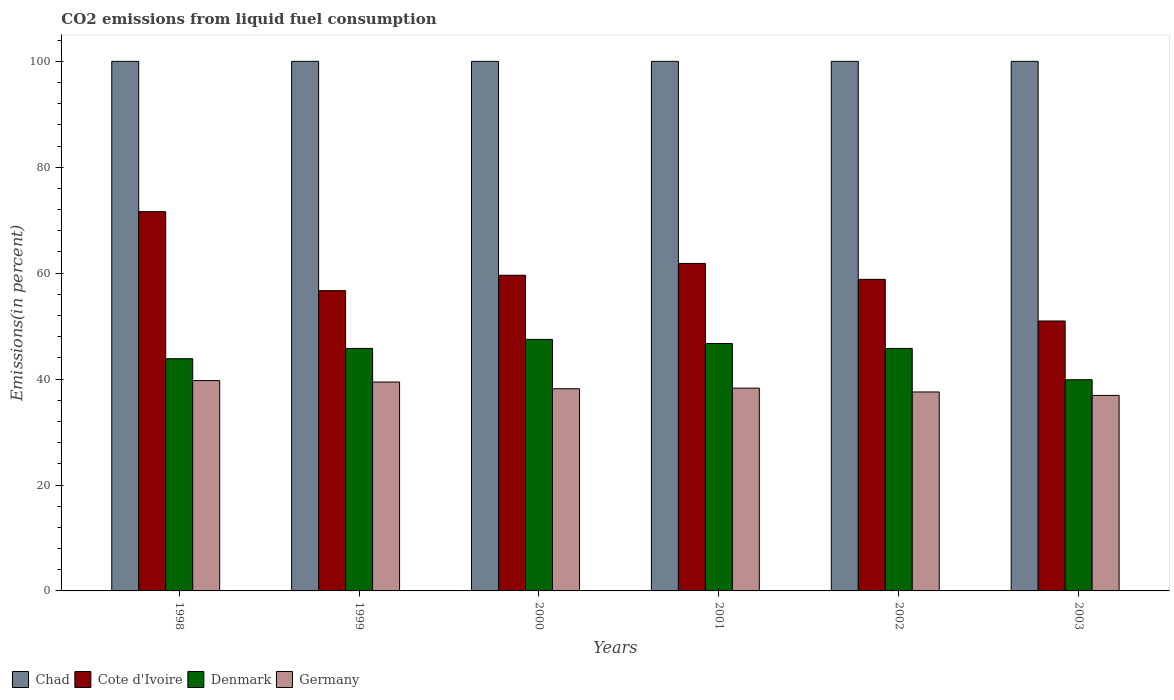How many bars are there on the 5th tick from the right?
Your answer should be very brief. 4. What is the label of the 1st group of bars from the left?
Provide a succinct answer. 1998. What is the total CO2 emitted in Cote d'Ivoire in 2002?
Provide a succinct answer. 58.83. Across all years, what is the maximum total CO2 emitted in Cote d'Ivoire?
Offer a very short reply. 71.62. Across all years, what is the minimum total CO2 emitted in Denmark?
Make the answer very short. 39.88. In which year was the total CO2 emitted in Cote d'Ivoire maximum?
Your answer should be compact. 1998. What is the total total CO2 emitted in Chad in the graph?
Offer a very short reply. 600. What is the difference between the total CO2 emitted in Cote d'Ivoire in 2001 and the total CO2 emitted in Denmark in 1999?
Give a very brief answer. 16.05. What is the average total CO2 emitted in Cote d'Ivoire per year?
Your answer should be compact. 59.93. In the year 2000, what is the difference between the total CO2 emitted in Germany and total CO2 emitted in Chad?
Your answer should be compact. -61.82. In how many years, is the total CO2 emitted in Germany greater than 20 %?
Provide a short and direct response. 6. Is the total CO2 emitted in Denmark in 2001 less than that in 2002?
Keep it short and to the point. No. What is the difference between the highest and the second highest total CO2 emitted in Denmark?
Your answer should be very brief. 0.78. What is the difference between the highest and the lowest total CO2 emitted in Denmark?
Offer a terse response. 7.62. In how many years, is the total CO2 emitted in Chad greater than the average total CO2 emitted in Chad taken over all years?
Give a very brief answer. 0. What does the 4th bar from the right in 2000 represents?
Provide a succinct answer. Chad. Is it the case that in every year, the sum of the total CO2 emitted in Germany and total CO2 emitted in Denmark is greater than the total CO2 emitted in Cote d'Ivoire?
Your answer should be very brief. Yes. How many bars are there?
Make the answer very short. 24. How many years are there in the graph?
Your response must be concise. 6. Does the graph contain any zero values?
Give a very brief answer. No. Where does the legend appear in the graph?
Make the answer very short. Bottom left. How many legend labels are there?
Offer a terse response. 4. How are the legend labels stacked?
Your answer should be very brief. Horizontal. What is the title of the graph?
Provide a succinct answer. CO2 emissions from liquid fuel consumption. Does "Least developed countries" appear as one of the legend labels in the graph?
Offer a very short reply. No. What is the label or title of the Y-axis?
Keep it short and to the point. Emissions(in percent). What is the Emissions(in percent) in Cote d'Ivoire in 1998?
Offer a terse response. 71.62. What is the Emissions(in percent) of Denmark in 1998?
Make the answer very short. 43.85. What is the Emissions(in percent) in Germany in 1998?
Offer a terse response. 39.72. What is the Emissions(in percent) in Chad in 1999?
Your answer should be compact. 100. What is the Emissions(in percent) in Cote d'Ivoire in 1999?
Provide a short and direct response. 56.7. What is the Emissions(in percent) of Denmark in 1999?
Offer a very short reply. 45.79. What is the Emissions(in percent) of Germany in 1999?
Give a very brief answer. 39.45. What is the Emissions(in percent) in Cote d'Ivoire in 2000?
Offer a very short reply. 59.61. What is the Emissions(in percent) in Denmark in 2000?
Keep it short and to the point. 47.5. What is the Emissions(in percent) in Germany in 2000?
Provide a succinct answer. 38.18. What is the Emissions(in percent) in Cote d'Ivoire in 2001?
Keep it short and to the point. 61.84. What is the Emissions(in percent) in Denmark in 2001?
Your answer should be compact. 46.72. What is the Emissions(in percent) of Germany in 2001?
Give a very brief answer. 38.29. What is the Emissions(in percent) in Cote d'Ivoire in 2002?
Make the answer very short. 58.83. What is the Emissions(in percent) of Denmark in 2002?
Ensure brevity in your answer.  45.79. What is the Emissions(in percent) of Germany in 2002?
Keep it short and to the point. 37.57. What is the Emissions(in percent) of Cote d'Ivoire in 2003?
Give a very brief answer. 50.97. What is the Emissions(in percent) of Denmark in 2003?
Your response must be concise. 39.88. What is the Emissions(in percent) in Germany in 2003?
Provide a short and direct response. 36.92. Across all years, what is the maximum Emissions(in percent) of Chad?
Provide a succinct answer. 100. Across all years, what is the maximum Emissions(in percent) in Cote d'Ivoire?
Keep it short and to the point. 71.62. Across all years, what is the maximum Emissions(in percent) of Denmark?
Ensure brevity in your answer.  47.5. Across all years, what is the maximum Emissions(in percent) of Germany?
Your answer should be compact. 39.72. Across all years, what is the minimum Emissions(in percent) of Cote d'Ivoire?
Provide a succinct answer. 50.97. Across all years, what is the minimum Emissions(in percent) of Denmark?
Your answer should be compact. 39.88. Across all years, what is the minimum Emissions(in percent) of Germany?
Give a very brief answer. 36.92. What is the total Emissions(in percent) of Chad in the graph?
Make the answer very short. 600. What is the total Emissions(in percent) in Cote d'Ivoire in the graph?
Make the answer very short. 359.58. What is the total Emissions(in percent) of Denmark in the graph?
Your answer should be compact. 269.53. What is the total Emissions(in percent) of Germany in the graph?
Offer a terse response. 230.13. What is the difference between the Emissions(in percent) in Chad in 1998 and that in 1999?
Keep it short and to the point. 0. What is the difference between the Emissions(in percent) in Cote d'Ivoire in 1998 and that in 1999?
Provide a succinct answer. 14.92. What is the difference between the Emissions(in percent) in Denmark in 1998 and that in 1999?
Keep it short and to the point. -1.95. What is the difference between the Emissions(in percent) of Germany in 1998 and that in 1999?
Your answer should be compact. 0.28. What is the difference between the Emissions(in percent) in Cote d'Ivoire in 1998 and that in 2000?
Offer a very short reply. 12.01. What is the difference between the Emissions(in percent) of Denmark in 1998 and that in 2000?
Offer a terse response. -3.65. What is the difference between the Emissions(in percent) of Germany in 1998 and that in 2000?
Provide a short and direct response. 1.54. What is the difference between the Emissions(in percent) of Chad in 1998 and that in 2001?
Provide a succinct answer. 0. What is the difference between the Emissions(in percent) in Cote d'Ivoire in 1998 and that in 2001?
Ensure brevity in your answer.  9.78. What is the difference between the Emissions(in percent) of Denmark in 1998 and that in 2001?
Provide a succinct answer. -2.87. What is the difference between the Emissions(in percent) in Germany in 1998 and that in 2001?
Make the answer very short. 1.43. What is the difference between the Emissions(in percent) of Cote d'Ivoire in 1998 and that in 2002?
Your response must be concise. 12.79. What is the difference between the Emissions(in percent) of Denmark in 1998 and that in 2002?
Your answer should be compact. -1.94. What is the difference between the Emissions(in percent) in Germany in 1998 and that in 2002?
Keep it short and to the point. 2.15. What is the difference between the Emissions(in percent) of Chad in 1998 and that in 2003?
Provide a succinct answer. 0. What is the difference between the Emissions(in percent) of Cote d'Ivoire in 1998 and that in 2003?
Make the answer very short. 20.64. What is the difference between the Emissions(in percent) in Denmark in 1998 and that in 2003?
Make the answer very short. 3.97. What is the difference between the Emissions(in percent) of Germany in 1998 and that in 2003?
Offer a terse response. 2.8. What is the difference between the Emissions(in percent) in Cote d'Ivoire in 1999 and that in 2000?
Provide a short and direct response. -2.91. What is the difference between the Emissions(in percent) of Denmark in 1999 and that in 2000?
Provide a succinct answer. -1.71. What is the difference between the Emissions(in percent) of Germany in 1999 and that in 2000?
Provide a succinct answer. 1.27. What is the difference between the Emissions(in percent) of Chad in 1999 and that in 2001?
Offer a terse response. 0. What is the difference between the Emissions(in percent) in Cote d'Ivoire in 1999 and that in 2001?
Offer a terse response. -5.14. What is the difference between the Emissions(in percent) of Denmark in 1999 and that in 2001?
Your answer should be very brief. -0.92. What is the difference between the Emissions(in percent) of Germany in 1999 and that in 2001?
Give a very brief answer. 1.15. What is the difference between the Emissions(in percent) of Chad in 1999 and that in 2002?
Provide a succinct answer. 0. What is the difference between the Emissions(in percent) of Cote d'Ivoire in 1999 and that in 2002?
Your answer should be compact. -2.13. What is the difference between the Emissions(in percent) of Denmark in 1999 and that in 2002?
Your answer should be very brief. 0.01. What is the difference between the Emissions(in percent) in Germany in 1999 and that in 2002?
Make the answer very short. 1.88. What is the difference between the Emissions(in percent) of Cote d'Ivoire in 1999 and that in 2003?
Your response must be concise. 5.73. What is the difference between the Emissions(in percent) of Denmark in 1999 and that in 2003?
Your answer should be compact. 5.91. What is the difference between the Emissions(in percent) in Germany in 1999 and that in 2003?
Your answer should be very brief. 2.52. What is the difference between the Emissions(in percent) of Cote d'Ivoire in 2000 and that in 2001?
Offer a very short reply. -2.23. What is the difference between the Emissions(in percent) in Denmark in 2000 and that in 2001?
Provide a succinct answer. 0.78. What is the difference between the Emissions(in percent) in Germany in 2000 and that in 2001?
Ensure brevity in your answer.  -0.11. What is the difference between the Emissions(in percent) in Cote d'Ivoire in 2000 and that in 2002?
Provide a short and direct response. 0.78. What is the difference between the Emissions(in percent) in Denmark in 2000 and that in 2002?
Give a very brief answer. 1.71. What is the difference between the Emissions(in percent) in Germany in 2000 and that in 2002?
Make the answer very short. 0.61. What is the difference between the Emissions(in percent) of Cote d'Ivoire in 2000 and that in 2003?
Ensure brevity in your answer.  8.64. What is the difference between the Emissions(in percent) in Denmark in 2000 and that in 2003?
Offer a terse response. 7.62. What is the difference between the Emissions(in percent) in Germany in 2000 and that in 2003?
Make the answer very short. 1.26. What is the difference between the Emissions(in percent) of Cote d'Ivoire in 2001 and that in 2002?
Offer a terse response. 3.01. What is the difference between the Emissions(in percent) of Denmark in 2001 and that in 2002?
Offer a very short reply. 0.93. What is the difference between the Emissions(in percent) of Germany in 2001 and that in 2002?
Offer a terse response. 0.72. What is the difference between the Emissions(in percent) in Chad in 2001 and that in 2003?
Keep it short and to the point. 0. What is the difference between the Emissions(in percent) of Cote d'Ivoire in 2001 and that in 2003?
Keep it short and to the point. 10.87. What is the difference between the Emissions(in percent) in Denmark in 2001 and that in 2003?
Your answer should be very brief. 6.84. What is the difference between the Emissions(in percent) of Germany in 2001 and that in 2003?
Your answer should be compact. 1.37. What is the difference between the Emissions(in percent) of Chad in 2002 and that in 2003?
Keep it short and to the point. 0. What is the difference between the Emissions(in percent) of Cote d'Ivoire in 2002 and that in 2003?
Ensure brevity in your answer.  7.86. What is the difference between the Emissions(in percent) in Denmark in 2002 and that in 2003?
Offer a terse response. 5.91. What is the difference between the Emissions(in percent) of Germany in 2002 and that in 2003?
Make the answer very short. 0.65. What is the difference between the Emissions(in percent) of Chad in 1998 and the Emissions(in percent) of Cote d'Ivoire in 1999?
Give a very brief answer. 43.3. What is the difference between the Emissions(in percent) in Chad in 1998 and the Emissions(in percent) in Denmark in 1999?
Offer a terse response. 54.21. What is the difference between the Emissions(in percent) in Chad in 1998 and the Emissions(in percent) in Germany in 1999?
Your answer should be very brief. 60.55. What is the difference between the Emissions(in percent) in Cote d'Ivoire in 1998 and the Emissions(in percent) in Denmark in 1999?
Keep it short and to the point. 25.82. What is the difference between the Emissions(in percent) of Cote d'Ivoire in 1998 and the Emissions(in percent) of Germany in 1999?
Your response must be concise. 32.17. What is the difference between the Emissions(in percent) in Denmark in 1998 and the Emissions(in percent) in Germany in 1999?
Your answer should be compact. 4.4. What is the difference between the Emissions(in percent) in Chad in 1998 and the Emissions(in percent) in Cote d'Ivoire in 2000?
Provide a short and direct response. 40.39. What is the difference between the Emissions(in percent) of Chad in 1998 and the Emissions(in percent) of Denmark in 2000?
Offer a terse response. 52.5. What is the difference between the Emissions(in percent) of Chad in 1998 and the Emissions(in percent) of Germany in 2000?
Offer a terse response. 61.82. What is the difference between the Emissions(in percent) of Cote d'Ivoire in 1998 and the Emissions(in percent) of Denmark in 2000?
Your answer should be compact. 24.12. What is the difference between the Emissions(in percent) of Cote d'Ivoire in 1998 and the Emissions(in percent) of Germany in 2000?
Keep it short and to the point. 33.44. What is the difference between the Emissions(in percent) in Denmark in 1998 and the Emissions(in percent) in Germany in 2000?
Your response must be concise. 5.67. What is the difference between the Emissions(in percent) of Chad in 1998 and the Emissions(in percent) of Cote d'Ivoire in 2001?
Your response must be concise. 38.16. What is the difference between the Emissions(in percent) in Chad in 1998 and the Emissions(in percent) in Denmark in 2001?
Make the answer very short. 53.28. What is the difference between the Emissions(in percent) in Chad in 1998 and the Emissions(in percent) in Germany in 2001?
Offer a terse response. 61.71. What is the difference between the Emissions(in percent) in Cote d'Ivoire in 1998 and the Emissions(in percent) in Denmark in 2001?
Provide a short and direct response. 24.9. What is the difference between the Emissions(in percent) in Cote d'Ivoire in 1998 and the Emissions(in percent) in Germany in 2001?
Provide a succinct answer. 33.33. What is the difference between the Emissions(in percent) of Denmark in 1998 and the Emissions(in percent) of Germany in 2001?
Your response must be concise. 5.56. What is the difference between the Emissions(in percent) in Chad in 1998 and the Emissions(in percent) in Cote d'Ivoire in 2002?
Your response must be concise. 41.17. What is the difference between the Emissions(in percent) of Chad in 1998 and the Emissions(in percent) of Denmark in 2002?
Your answer should be very brief. 54.21. What is the difference between the Emissions(in percent) of Chad in 1998 and the Emissions(in percent) of Germany in 2002?
Keep it short and to the point. 62.43. What is the difference between the Emissions(in percent) of Cote d'Ivoire in 1998 and the Emissions(in percent) of Denmark in 2002?
Provide a succinct answer. 25.83. What is the difference between the Emissions(in percent) of Cote d'Ivoire in 1998 and the Emissions(in percent) of Germany in 2002?
Provide a short and direct response. 34.05. What is the difference between the Emissions(in percent) in Denmark in 1998 and the Emissions(in percent) in Germany in 2002?
Your answer should be compact. 6.28. What is the difference between the Emissions(in percent) in Chad in 1998 and the Emissions(in percent) in Cote d'Ivoire in 2003?
Your answer should be very brief. 49.03. What is the difference between the Emissions(in percent) of Chad in 1998 and the Emissions(in percent) of Denmark in 2003?
Provide a short and direct response. 60.12. What is the difference between the Emissions(in percent) of Chad in 1998 and the Emissions(in percent) of Germany in 2003?
Your answer should be compact. 63.08. What is the difference between the Emissions(in percent) of Cote d'Ivoire in 1998 and the Emissions(in percent) of Denmark in 2003?
Your answer should be very brief. 31.74. What is the difference between the Emissions(in percent) of Cote d'Ivoire in 1998 and the Emissions(in percent) of Germany in 2003?
Provide a short and direct response. 34.7. What is the difference between the Emissions(in percent) of Denmark in 1998 and the Emissions(in percent) of Germany in 2003?
Provide a short and direct response. 6.93. What is the difference between the Emissions(in percent) of Chad in 1999 and the Emissions(in percent) of Cote d'Ivoire in 2000?
Offer a terse response. 40.39. What is the difference between the Emissions(in percent) of Chad in 1999 and the Emissions(in percent) of Denmark in 2000?
Your answer should be compact. 52.5. What is the difference between the Emissions(in percent) in Chad in 1999 and the Emissions(in percent) in Germany in 2000?
Provide a succinct answer. 61.82. What is the difference between the Emissions(in percent) of Cote d'Ivoire in 1999 and the Emissions(in percent) of Denmark in 2000?
Your response must be concise. 9.2. What is the difference between the Emissions(in percent) in Cote d'Ivoire in 1999 and the Emissions(in percent) in Germany in 2000?
Keep it short and to the point. 18.52. What is the difference between the Emissions(in percent) in Denmark in 1999 and the Emissions(in percent) in Germany in 2000?
Your answer should be very brief. 7.61. What is the difference between the Emissions(in percent) of Chad in 1999 and the Emissions(in percent) of Cote d'Ivoire in 2001?
Keep it short and to the point. 38.16. What is the difference between the Emissions(in percent) in Chad in 1999 and the Emissions(in percent) in Denmark in 2001?
Your response must be concise. 53.28. What is the difference between the Emissions(in percent) of Chad in 1999 and the Emissions(in percent) of Germany in 2001?
Give a very brief answer. 61.71. What is the difference between the Emissions(in percent) of Cote d'Ivoire in 1999 and the Emissions(in percent) of Denmark in 2001?
Keep it short and to the point. 9.98. What is the difference between the Emissions(in percent) in Cote d'Ivoire in 1999 and the Emissions(in percent) in Germany in 2001?
Offer a terse response. 18.41. What is the difference between the Emissions(in percent) of Denmark in 1999 and the Emissions(in percent) of Germany in 2001?
Make the answer very short. 7.5. What is the difference between the Emissions(in percent) of Chad in 1999 and the Emissions(in percent) of Cote d'Ivoire in 2002?
Give a very brief answer. 41.17. What is the difference between the Emissions(in percent) in Chad in 1999 and the Emissions(in percent) in Denmark in 2002?
Ensure brevity in your answer.  54.21. What is the difference between the Emissions(in percent) of Chad in 1999 and the Emissions(in percent) of Germany in 2002?
Offer a very short reply. 62.43. What is the difference between the Emissions(in percent) of Cote d'Ivoire in 1999 and the Emissions(in percent) of Denmark in 2002?
Your response must be concise. 10.91. What is the difference between the Emissions(in percent) in Cote d'Ivoire in 1999 and the Emissions(in percent) in Germany in 2002?
Your response must be concise. 19.13. What is the difference between the Emissions(in percent) in Denmark in 1999 and the Emissions(in percent) in Germany in 2002?
Keep it short and to the point. 8.22. What is the difference between the Emissions(in percent) of Chad in 1999 and the Emissions(in percent) of Cote d'Ivoire in 2003?
Give a very brief answer. 49.03. What is the difference between the Emissions(in percent) in Chad in 1999 and the Emissions(in percent) in Denmark in 2003?
Offer a very short reply. 60.12. What is the difference between the Emissions(in percent) in Chad in 1999 and the Emissions(in percent) in Germany in 2003?
Your answer should be very brief. 63.08. What is the difference between the Emissions(in percent) in Cote d'Ivoire in 1999 and the Emissions(in percent) in Denmark in 2003?
Your answer should be very brief. 16.82. What is the difference between the Emissions(in percent) in Cote d'Ivoire in 1999 and the Emissions(in percent) in Germany in 2003?
Your answer should be very brief. 19.78. What is the difference between the Emissions(in percent) in Denmark in 1999 and the Emissions(in percent) in Germany in 2003?
Ensure brevity in your answer.  8.87. What is the difference between the Emissions(in percent) in Chad in 2000 and the Emissions(in percent) in Cote d'Ivoire in 2001?
Provide a short and direct response. 38.16. What is the difference between the Emissions(in percent) in Chad in 2000 and the Emissions(in percent) in Denmark in 2001?
Give a very brief answer. 53.28. What is the difference between the Emissions(in percent) of Chad in 2000 and the Emissions(in percent) of Germany in 2001?
Give a very brief answer. 61.71. What is the difference between the Emissions(in percent) of Cote d'Ivoire in 2000 and the Emissions(in percent) of Denmark in 2001?
Keep it short and to the point. 12.89. What is the difference between the Emissions(in percent) of Cote d'Ivoire in 2000 and the Emissions(in percent) of Germany in 2001?
Offer a very short reply. 21.32. What is the difference between the Emissions(in percent) in Denmark in 2000 and the Emissions(in percent) in Germany in 2001?
Your answer should be compact. 9.21. What is the difference between the Emissions(in percent) of Chad in 2000 and the Emissions(in percent) of Cote d'Ivoire in 2002?
Offer a very short reply. 41.17. What is the difference between the Emissions(in percent) of Chad in 2000 and the Emissions(in percent) of Denmark in 2002?
Give a very brief answer. 54.21. What is the difference between the Emissions(in percent) of Chad in 2000 and the Emissions(in percent) of Germany in 2002?
Offer a terse response. 62.43. What is the difference between the Emissions(in percent) of Cote d'Ivoire in 2000 and the Emissions(in percent) of Denmark in 2002?
Your response must be concise. 13.82. What is the difference between the Emissions(in percent) in Cote d'Ivoire in 2000 and the Emissions(in percent) in Germany in 2002?
Offer a terse response. 22.04. What is the difference between the Emissions(in percent) of Denmark in 2000 and the Emissions(in percent) of Germany in 2002?
Ensure brevity in your answer.  9.93. What is the difference between the Emissions(in percent) of Chad in 2000 and the Emissions(in percent) of Cote d'Ivoire in 2003?
Offer a terse response. 49.03. What is the difference between the Emissions(in percent) in Chad in 2000 and the Emissions(in percent) in Denmark in 2003?
Provide a succinct answer. 60.12. What is the difference between the Emissions(in percent) of Chad in 2000 and the Emissions(in percent) of Germany in 2003?
Your answer should be compact. 63.08. What is the difference between the Emissions(in percent) in Cote d'Ivoire in 2000 and the Emissions(in percent) in Denmark in 2003?
Ensure brevity in your answer.  19.73. What is the difference between the Emissions(in percent) in Cote d'Ivoire in 2000 and the Emissions(in percent) in Germany in 2003?
Your response must be concise. 22.69. What is the difference between the Emissions(in percent) of Denmark in 2000 and the Emissions(in percent) of Germany in 2003?
Give a very brief answer. 10.58. What is the difference between the Emissions(in percent) of Chad in 2001 and the Emissions(in percent) of Cote d'Ivoire in 2002?
Provide a succinct answer. 41.17. What is the difference between the Emissions(in percent) of Chad in 2001 and the Emissions(in percent) of Denmark in 2002?
Ensure brevity in your answer.  54.21. What is the difference between the Emissions(in percent) of Chad in 2001 and the Emissions(in percent) of Germany in 2002?
Make the answer very short. 62.43. What is the difference between the Emissions(in percent) in Cote d'Ivoire in 2001 and the Emissions(in percent) in Denmark in 2002?
Your answer should be very brief. 16.05. What is the difference between the Emissions(in percent) in Cote d'Ivoire in 2001 and the Emissions(in percent) in Germany in 2002?
Provide a succinct answer. 24.27. What is the difference between the Emissions(in percent) of Denmark in 2001 and the Emissions(in percent) of Germany in 2002?
Provide a succinct answer. 9.15. What is the difference between the Emissions(in percent) in Chad in 2001 and the Emissions(in percent) in Cote d'Ivoire in 2003?
Provide a short and direct response. 49.03. What is the difference between the Emissions(in percent) of Chad in 2001 and the Emissions(in percent) of Denmark in 2003?
Offer a terse response. 60.12. What is the difference between the Emissions(in percent) of Chad in 2001 and the Emissions(in percent) of Germany in 2003?
Offer a very short reply. 63.08. What is the difference between the Emissions(in percent) in Cote d'Ivoire in 2001 and the Emissions(in percent) in Denmark in 2003?
Provide a short and direct response. 21.96. What is the difference between the Emissions(in percent) in Cote d'Ivoire in 2001 and the Emissions(in percent) in Germany in 2003?
Your answer should be compact. 24.92. What is the difference between the Emissions(in percent) in Denmark in 2001 and the Emissions(in percent) in Germany in 2003?
Your answer should be very brief. 9.8. What is the difference between the Emissions(in percent) in Chad in 2002 and the Emissions(in percent) in Cote d'Ivoire in 2003?
Provide a succinct answer. 49.03. What is the difference between the Emissions(in percent) in Chad in 2002 and the Emissions(in percent) in Denmark in 2003?
Make the answer very short. 60.12. What is the difference between the Emissions(in percent) of Chad in 2002 and the Emissions(in percent) of Germany in 2003?
Provide a short and direct response. 63.08. What is the difference between the Emissions(in percent) in Cote d'Ivoire in 2002 and the Emissions(in percent) in Denmark in 2003?
Provide a succinct answer. 18.95. What is the difference between the Emissions(in percent) in Cote d'Ivoire in 2002 and the Emissions(in percent) in Germany in 2003?
Give a very brief answer. 21.91. What is the difference between the Emissions(in percent) in Denmark in 2002 and the Emissions(in percent) in Germany in 2003?
Provide a succinct answer. 8.87. What is the average Emissions(in percent) in Chad per year?
Offer a very short reply. 100. What is the average Emissions(in percent) of Cote d'Ivoire per year?
Offer a very short reply. 59.93. What is the average Emissions(in percent) of Denmark per year?
Provide a short and direct response. 44.92. What is the average Emissions(in percent) of Germany per year?
Offer a very short reply. 38.35. In the year 1998, what is the difference between the Emissions(in percent) of Chad and Emissions(in percent) of Cote d'Ivoire?
Give a very brief answer. 28.38. In the year 1998, what is the difference between the Emissions(in percent) of Chad and Emissions(in percent) of Denmark?
Your answer should be compact. 56.15. In the year 1998, what is the difference between the Emissions(in percent) of Chad and Emissions(in percent) of Germany?
Offer a very short reply. 60.28. In the year 1998, what is the difference between the Emissions(in percent) in Cote d'Ivoire and Emissions(in percent) in Denmark?
Keep it short and to the point. 27.77. In the year 1998, what is the difference between the Emissions(in percent) of Cote d'Ivoire and Emissions(in percent) of Germany?
Your answer should be compact. 31.9. In the year 1998, what is the difference between the Emissions(in percent) in Denmark and Emissions(in percent) in Germany?
Give a very brief answer. 4.13. In the year 1999, what is the difference between the Emissions(in percent) of Chad and Emissions(in percent) of Cote d'Ivoire?
Offer a very short reply. 43.3. In the year 1999, what is the difference between the Emissions(in percent) of Chad and Emissions(in percent) of Denmark?
Provide a short and direct response. 54.21. In the year 1999, what is the difference between the Emissions(in percent) of Chad and Emissions(in percent) of Germany?
Keep it short and to the point. 60.55. In the year 1999, what is the difference between the Emissions(in percent) in Cote d'Ivoire and Emissions(in percent) in Denmark?
Keep it short and to the point. 10.91. In the year 1999, what is the difference between the Emissions(in percent) of Cote d'Ivoire and Emissions(in percent) of Germany?
Give a very brief answer. 17.25. In the year 1999, what is the difference between the Emissions(in percent) in Denmark and Emissions(in percent) in Germany?
Give a very brief answer. 6.35. In the year 2000, what is the difference between the Emissions(in percent) in Chad and Emissions(in percent) in Cote d'Ivoire?
Provide a succinct answer. 40.39. In the year 2000, what is the difference between the Emissions(in percent) in Chad and Emissions(in percent) in Denmark?
Your response must be concise. 52.5. In the year 2000, what is the difference between the Emissions(in percent) of Chad and Emissions(in percent) of Germany?
Provide a succinct answer. 61.82. In the year 2000, what is the difference between the Emissions(in percent) in Cote d'Ivoire and Emissions(in percent) in Denmark?
Your answer should be compact. 12.11. In the year 2000, what is the difference between the Emissions(in percent) in Cote d'Ivoire and Emissions(in percent) in Germany?
Provide a short and direct response. 21.43. In the year 2000, what is the difference between the Emissions(in percent) of Denmark and Emissions(in percent) of Germany?
Your answer should be compact. 9.32. In the year 2001, what is the difference between the Emissions(in percent) in Chad and Emissions(in percent) in Cote d'Ivoire?
Offer a terse response. 38.16. In the year 2001, what is the difference between the Emissions(in percent) in Chad and Emissions(in percent) in Denmark?
Ensure brevity in your answer.  53.28. In the year 2001, what is the difference between the Emissions(in percent) of Chad and Emissions(in percent) of Germany?
Your answer should be very brief. 61.71. In the year 2001, what is the difference between the Emissions(in percent) of Cote d'Ivoire and Emissions(in percent) of Denmark?
Your answer should be compact. 15.12. In the year 2001, what is the difference between the Emissions(in percent) of Cote d'Ivoire and Emissions(in percent) of Germany?
Your answer should be compact. 23.55. In the year 2001, what is the difference between the Emissions(in percent) of Denmark and Emissions(in percent) of Germany?
Offer a terse response. 8.43. In the year 2002, what is the difference between the Emissions(in percent) in Chad and Emissions(in percent) in Cote d'Ivoire?
Make the answer very short. 41.17. In the year 2002, what is the difference between the Emissions(in percent) of Chad and Emissions(in percent) of Denmark?
Provide a short and direct response. 54.21. In the year 2002, what is the difference between the Emissions(in percent) of Chad and Emissions(in percent) of Germany?
Offer a very short reply. 62.43. In the year 2002, what is the difference between the Emissions(in percent) in Cote d'Ivoire and Emissions(in percent) in Denmark?
Offer a very short reply. 13.05. In the year 2002, what is the difference between the Emissions(in percent) of Cote d'Ivoire and Emissions(in percent) of Germany?
Your response must be concise. 21.26. In the year 2002, what is the difference between the Emissions(in percent) in Denmark and Emissions(in percent) in Germany?
Give a very brief answer. 8.22. In the year 2003, what is the difference between the Emissions(in percent) in Chad and Emissions(in percent) in Cote d'Ivoire?
Offer a terse response. 49.03. In the year 2003, what is the difference between the Emissions(in percent) in Chad and Emissions(in percent) in Denmark?
Offer a very short reply. 60.12. In the year 2003, what is the difference between the Emissions(in percent) of Chad and Emissions(in percent) of Germany?
Your response must be concise. 63.08. In the year 2003, what is the difference between the Emissions(in percent) of Cote d'Ivoire and Emissions(in percent) of Denmark?
Provide a short and direct response. 11.09. In the year 2003, what is the difference between the Emissions(in percent) in Cote d'Ivoire and Emissions(in percent) in Germany?
Offer a very short reply. 14.05. In the year 2003, what is the difference between the Emissions(in percent) in Denmark and Emissions(in percent) in Germany?
Your answer should be compact. 2.96. What is the ratio of the Emissions(in percent) in Cote d'Ivoire in 1998 to that in 1999?
Give a very brief answer. 1.26. What is the ratio of the Emissions(in percent) of Denmark in 1998 to that in 1999?
Keep it short and to the point. 0.96. What is the ratio of the Emissions(in percent) of Germany in 1998 to that in 1999?
Give a very brief answer. 1.01. What is the ratio of the Emissions(in percent) of Cote d'Ivoire in 1998 to that in 2000?
Keep it short and to the point. 1.2. What is the ratio of the Emissions(in percent) in Germany in 1998 to that in 2000?
Keep it short and to the point. 1.04. What is the ratio of the Emissions(in percent) of Chad in 1998 to that in 2001?
Ensure brevity in your answer.  1. What is the ratio of the Emissions(in percent) in Cote d'Ivoire in 1998 to that in 2001?
Your answer should be very brief. 1.16. What is the ratio of the Emissions(in percent) of Denmark in 1998 to that in 2001?
Offer a very short reply. 0.94. What is the ratio of the Emissions(in percent) of Germany in 1998 to that in 2001?
Provide a succinct answer. 1.04. What is the ratio of the Emissions(in percent) in Chad in 1998 to that in 2002?
Give a very brief answer. 1. What is the ratio of the Emissions(in percent) in Cote d'Ivoire in 1998 to that in 2002?
Provide a succinct answer. 1.22. What is the ratio of the Emissions(in percent) of Denmark in 1998 to that in 2002?
Offer a terse response. 0.96. What is the ratio of the Emissions(in percent) of Germany in 1998 to that in 2002?
Give a very brief answer. 1.06. What is the ratio of the Emissions(in percent) of Cote d'Ivoire in 1998 to that in 2003?
Provide a short and direct response. 1.41. What is the ratio of the Emissions(in percent) in Denmark in 1998 to that in 2003?
Offer a terse response. 1.1. What is the ratio of the Emissions(in percent) of Germany in 1998 to that in 2003?
Provide a succinct answer. 1.08. What is the ratio of the Emissions(in percent) in Chad in 1999 to that in 2000?
Your answer should be very brief. 1. What is the ratio of the Emissions(in percent) in Cote d'Ivoire in 1999 to that in 2000?
Ensure brevity in your answer.  0.95. What is the ratio of the Emissions(in percent) of Denmark in 1999 to that in 2000?
Offer a terse response. 0.96. What is the ratio of the Emissions(in percent) in Germany in 1999 to that in 2000?
Your response must be concise. 1.03. What is the ratio of the Emissions(in percent) in Cote d'Ivoire in 1999 to that in 2001?
Your answer should be very brief. 0.92. What is the ratio of the Emissions(in percent) of Denmark in 1999 to that in 2001?
Give a very brief answer. 0.98. What is the ratio of the Emissions(in percent) of Germany in 1999 to that in 2001?
Ensure brevity in your answer.  1.03. What is the ratio of the Emissions(in percent) in Chad in 1999 to that in 2002?
Your response must be concise. 1. What is the ratio of the Emissions(in percent) in Cote d'Ivoire in 1999 to that in 2002?
Make the answer very short. 0.96. What is the ratio of the Emissions(in percent) in Denmark in 1999 to that in 2002?
Offer a very short reply. 1. What is the ratio of the Emissions(in percent) in Germany in 1999 to that in 2002?
Your response must be concise. 1.05. What is the ratio of the Emissions(in percent) in Cote d'Ivoire in 1999 to that in 2003?
Give a very brief answer. 1.11. What is the ratio of the Emissions(in percent) in Denmark in 1999 to that in 2003?
Your answer should be very brief. 1.15. What is the ratio of the Emissions(in percent) in Germany in 1999 to that in 2003?
Keep it short and to the point. 1.07. What is the ratio of the Emissions(in percent) in Cote d'Ivoire in 2000 to that in 2001?
Make the answer very short. 0.96. What is the ratio of the Emissions(in percent) in Denmark in 2000 to that in 2001?
Your answer should be compact. 1.02. What is the ratio of the Emissions(in percent) of Germany in 2000 to that in 2001?
Keep it short and to the point. 1. What is the ratio of the Emissions(in percent) in Cote d'Ivoire in 2000 to that in 2002?
Offer a very short reply. 1.01. What is the ratio of the Emissions(in percent) of Denmark in 2000 to that in 2002?
Make the answer very short. 1.04. What is the ratio of the Emissions(in percent) of Germany in 2000 to that in 2002?
Keep it short and to the point. 1.02. What is the ratio of the Emissions(in percent) of Chad in 2000 to that in 2003?
Ensure brevity in your answer.  1. What is the ratio of the Emissions(in percent) of Cote d'Ivoire in 2000 to that in 2003?
Offer a terse response. 1.17. What is the ratio of the Emissions(in percent) of Denmark in 2000 to that in 2003?
Offer a terse response. 1.19. What is the ratio of the Emissions(in percent) in Germany in 2000 to that in 2003?
Ensure brevity in your answer.  1.03. What is the ratio of the Emissions(in percent) in Cote d'Ivoire in 2001 to that in 2002?
Your answer should be compact. 1.05. What is the ratio of the Emissions(in percent) of Denmark in 2001 to that in 2002?
Give a very brief answer. 1.02. What is the ratio of the Emissions(in percent) of Germany in 2001 to that in 2002?
Keep it short and to the point. 1.02. What is the ratio of the Emissions(in percent) of Chad in 2001 to that in 2003?
Your answer should be compact. 1. What is the ratio of the Emissions(in percent) in Cote d'Ivoire in 2001 to that in 2003?
Ensure brevity in your answer.  1.21. What is the ratio of the Emissions(in percent) of Denmark in 2001 to that in 2003?
Provide a short and direct response. 1.17. What is the ratio of the Emissions(in percent) of Germany in 2001 to that in 2003?
Make the answer very short. 1.04. What is the ratio of the Emissions(in percent) in Chad in 2002 to that in 2003?
Your answer should be very brief. 1. What is the ratio of the Emissions(in percent) in Cote d'Ivoire in 2002 to that in 2003?
Your response must be concise. 1.15. What is the ratio of the Emissions(in percent) of Denmark in 2002 to that in 2003?
Ensure brevity in your answer.  1.15. What is the ratio of the Emissions(in percent) of Germany in 2002 to that in 2003?
Your answer should be very brief. 1.02. What is the difference between the highest and the second highest Emissions(in percent) in Chad?
Ensure brevity in your answer.  0. What is the difference between the highest and the second highest Emissions(in percent) of Cote d'Ivoire?
Make the answer very short. 9.78. What is the difference between the highest and the second highest Emissions(in percent) in Denmark?
Make the answer very short. 0.78. What is the difference between the highest and the second highest Emissions(in percent) in Germany?
Give a very brief answer. 0.28. What is the difference between the highest and the lowest Emissions(in percent) in Chad?
Offer a very short reply. 0. What is the difference between the highest and the lowest Emissions(in percent) of Cote d'Ivoire?
Your answer should be very brief. 20.64. What is the difference between the highest and the lowest Emissions(in percent) in Denmark?
Your answer should be very brief. 7.62. What is the difference between the highest and the lowest Emissions(in percent) of Germany?
Your answer should be very brief. 2.8. 